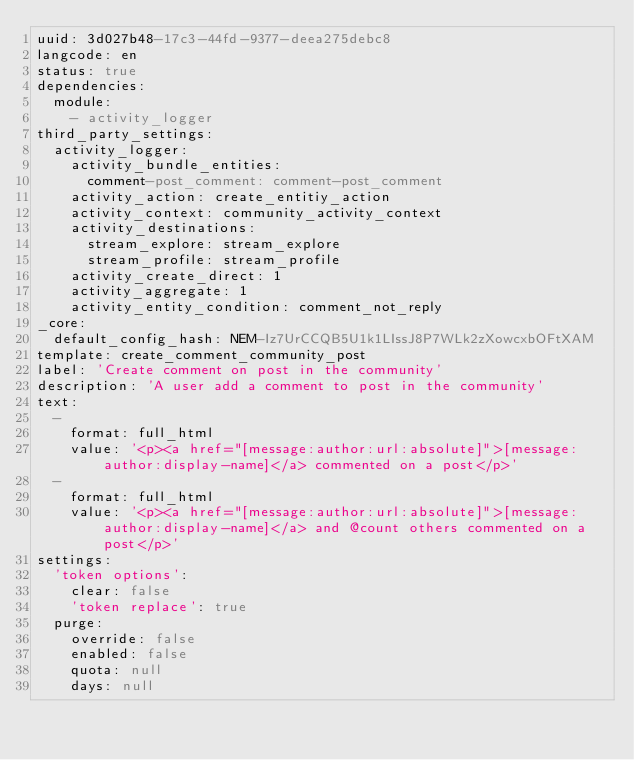Convert code to text. <code><loc_0><loc_0><loc_500><loc_500><_YAML_>uuid: 3d027b48-17c3-44fd-9377-deea275debc8
langcode: en
status: true
dependencies:
  module:
    - activity_logger
third_party_settings:
  activity_logger:
    activity_bundle_entities:
      comment-post_comment: comment-post_comment
    activity_action: create_entitiy_action
    activity_context: community_activity_context
    activity_destinations:
      stream_explore: stream_explore
      stream_profile: stream_profile
    activity_create_direct: 1
    activity_aggregate: 1
    activity_entity_condition: comment_not_reply
_core:
  default_config_hash: NEM-Iz7UrCCQB5U1k1LIssJ8P7WLk2zXowcxbOFtXAM
template: create_comment_community_post
label: 'Create comment on post in the community'
description: 'A user add a comment to post in the community'
text:
  -
    format: full_html
    value: '<p><a href="[message:author:url:absolute]">[message:author:display-name]</a> commented on a post</p>'
  -
    format: full_html
    value: '<p><a href="[message:author:url:absolute]">[message:author:display-name]</a> and @count others commented on a post</p>'
settings:
  'token options':
    clear: false
    'token replace': true
  purge:
    override: false
    enabled: false
    quota: null
    days: null
</code> 